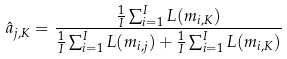Convert formula to latex. <formula><loc_0><loc_0><loc_500><loc_500>\hat { a } _ { j , K } = \frac { \frac { 1 } { I } \sum _ { i = 1 } ^ { I } L ( m _ { i , K } ) } { \frac { 1 } { I } \sum _ { i = 1 } ^ { I } L ( m _ { i , j } ) + \frac { 1 } { I } \sum _ { i = 1 } ^ { I } L ( m _ { i , K } ) }</formula> 